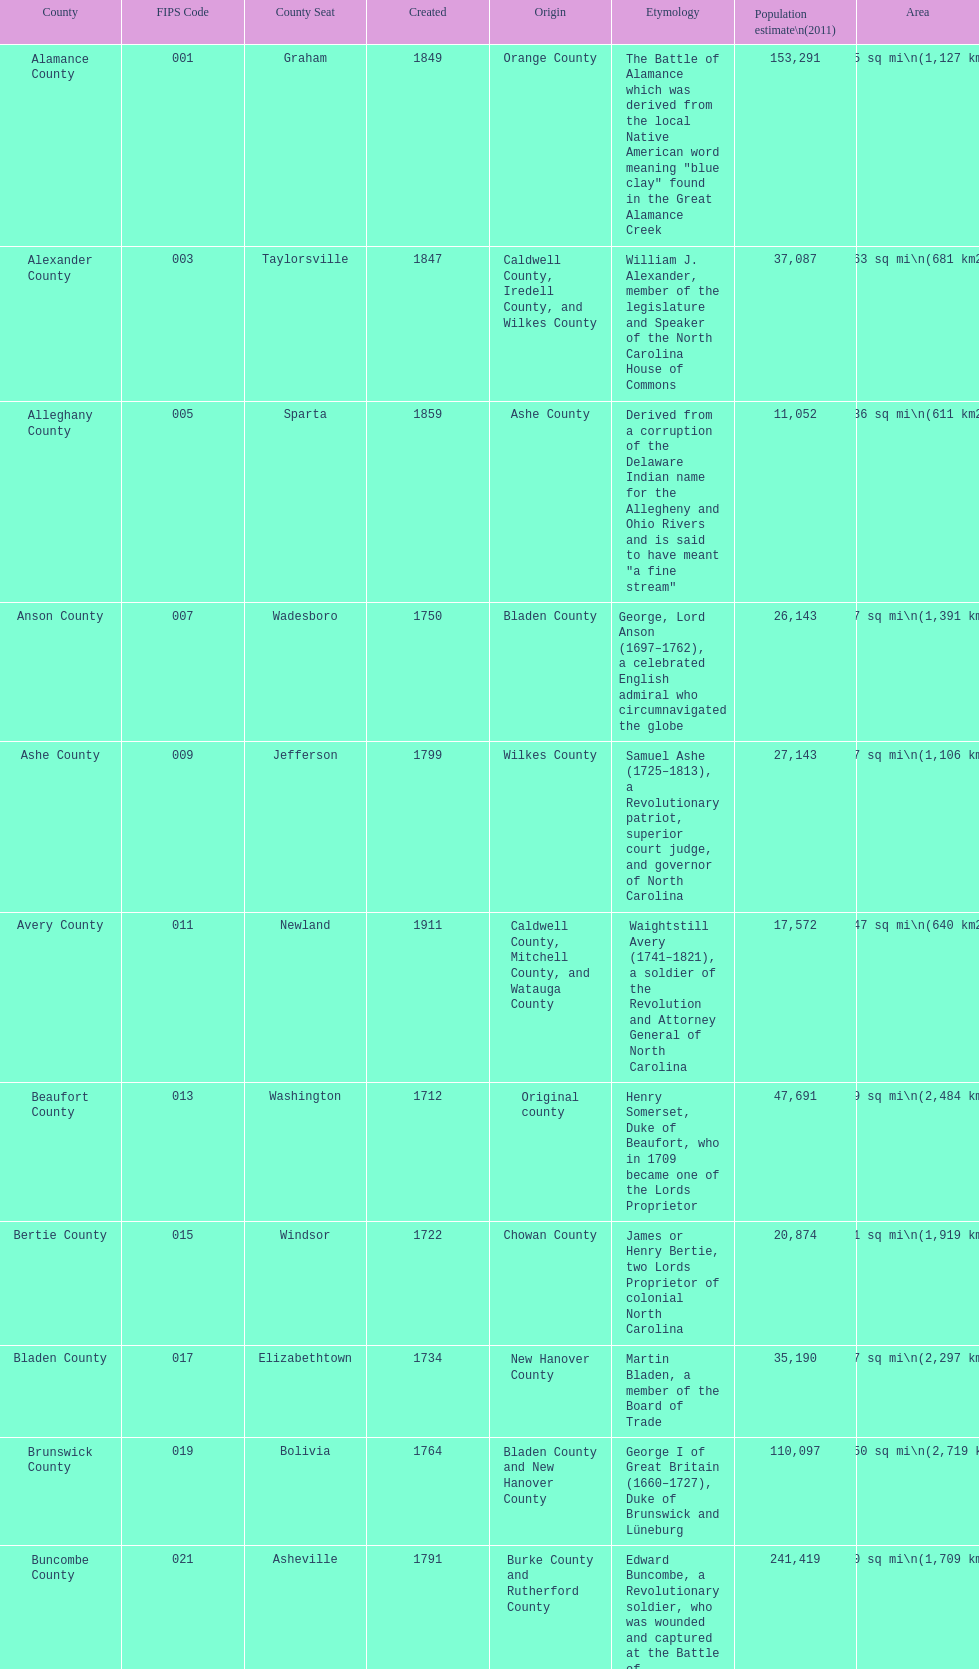Apart from mecklenburg, which county possesses the greatest number of residents? Wake County. 